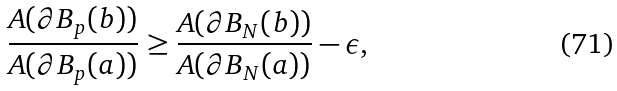<formula> <loc_0><loc_0><loc_500><loc_500>\frac { A ( \partial B _ { p } ( b ) ) } { A ( \partial B _ { p } ( a ) ) } \geq \frac { A ( \partial B _ { N } ( b ) ) } { A { ( \partial B _ { N } ( a ) ) } } - \epsilon ,</formula> 